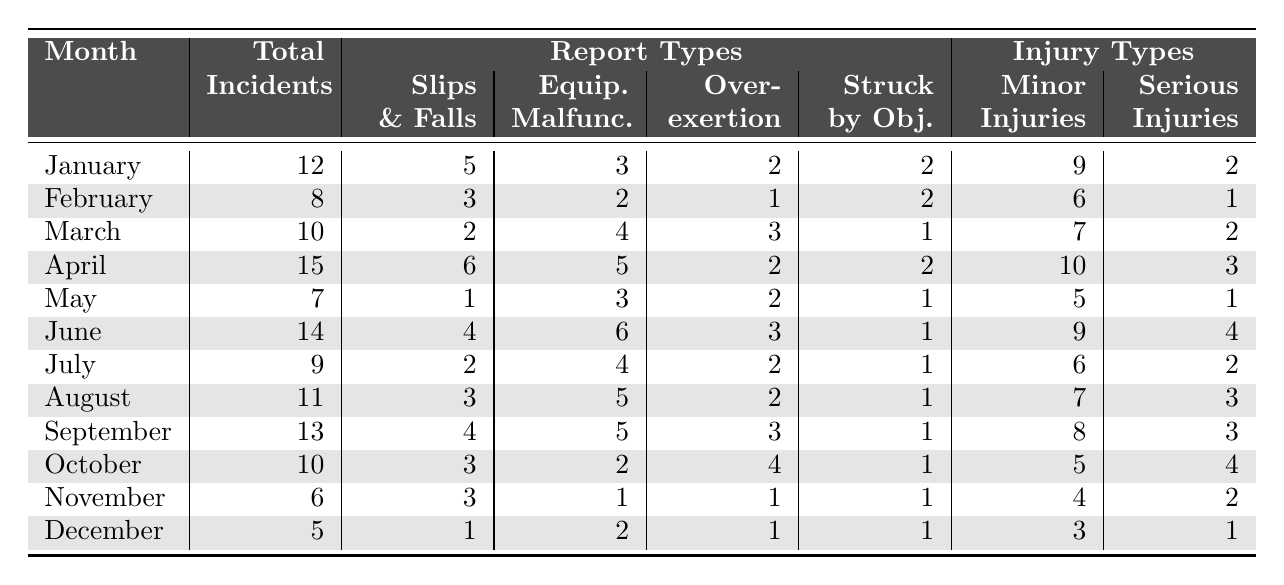What was the month with the highest number of safety incidents? By reviewing the total incidents column, April has the highest number of incidents, with a total of 15.
Answer: April How many total incidents were reported in June? The table indicates that there were 14 incidents reported in June.
Answer: 14 In which month did the highest number of equipment malfunctions occur? April had the most equipment malfunctions, with a total of 5 reported incidents.
Answer: April What is the average number of total incidents per month from January to December? The total number of incidents from all months is 12 + 8 + 10 + 15 + 7 + 14 + 9 + 11 + 13 + 10 + 6 + 5 =  120 incidents. There are 12 months, so the average is 120 / 12 = 10.
Answer: 10 How many months had more than 10 total incidents? The months with more than 10 incidents are January (12), April (15), June (14), August (11), and September (13). There are 5 months in total.
Answer: 5 Were there any months with no serious injuries reported? Yes, May, June, August, September, October, November, and December reported zero serious injuries.
Answer: Yes What was the most common report type throughout the year? By summing the report types across the months, slips and falls have a total of 30 incidents, more than any other type.
Answer: Slips and Falls How many total minor injuries were reported in the first half of the year (January to June)? The minor injuries from January to June total to 9 (January) + 6 (February) + 7 (March) + 10 (April) + 5 (May) + 9 (June) = 46 minor injuries.
Answer: 46 What is the difference between the number of serious injuries in October and December? October had 4 serious injuries, while December had 1. The difference is 4 - 1 = 3.
Answer: 3 Was the month of March safer than the month of November in terms of total incidents? March had 10 incidents while November had 6. Thus, March was not safer than November.
Answer: No 